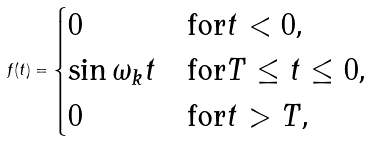Convert formula to latex. <formula><loc_0><loc_0><loc_500><loc_500>f ( t ) = \begin{cases} 0 & \text {for$t<0$,} \\ \sin \omega _ { k } t & \text {for$T\leq t\leq 0$,} \\ 0 & \text {for$t>T$,} \\ \end{cases}</formula> 